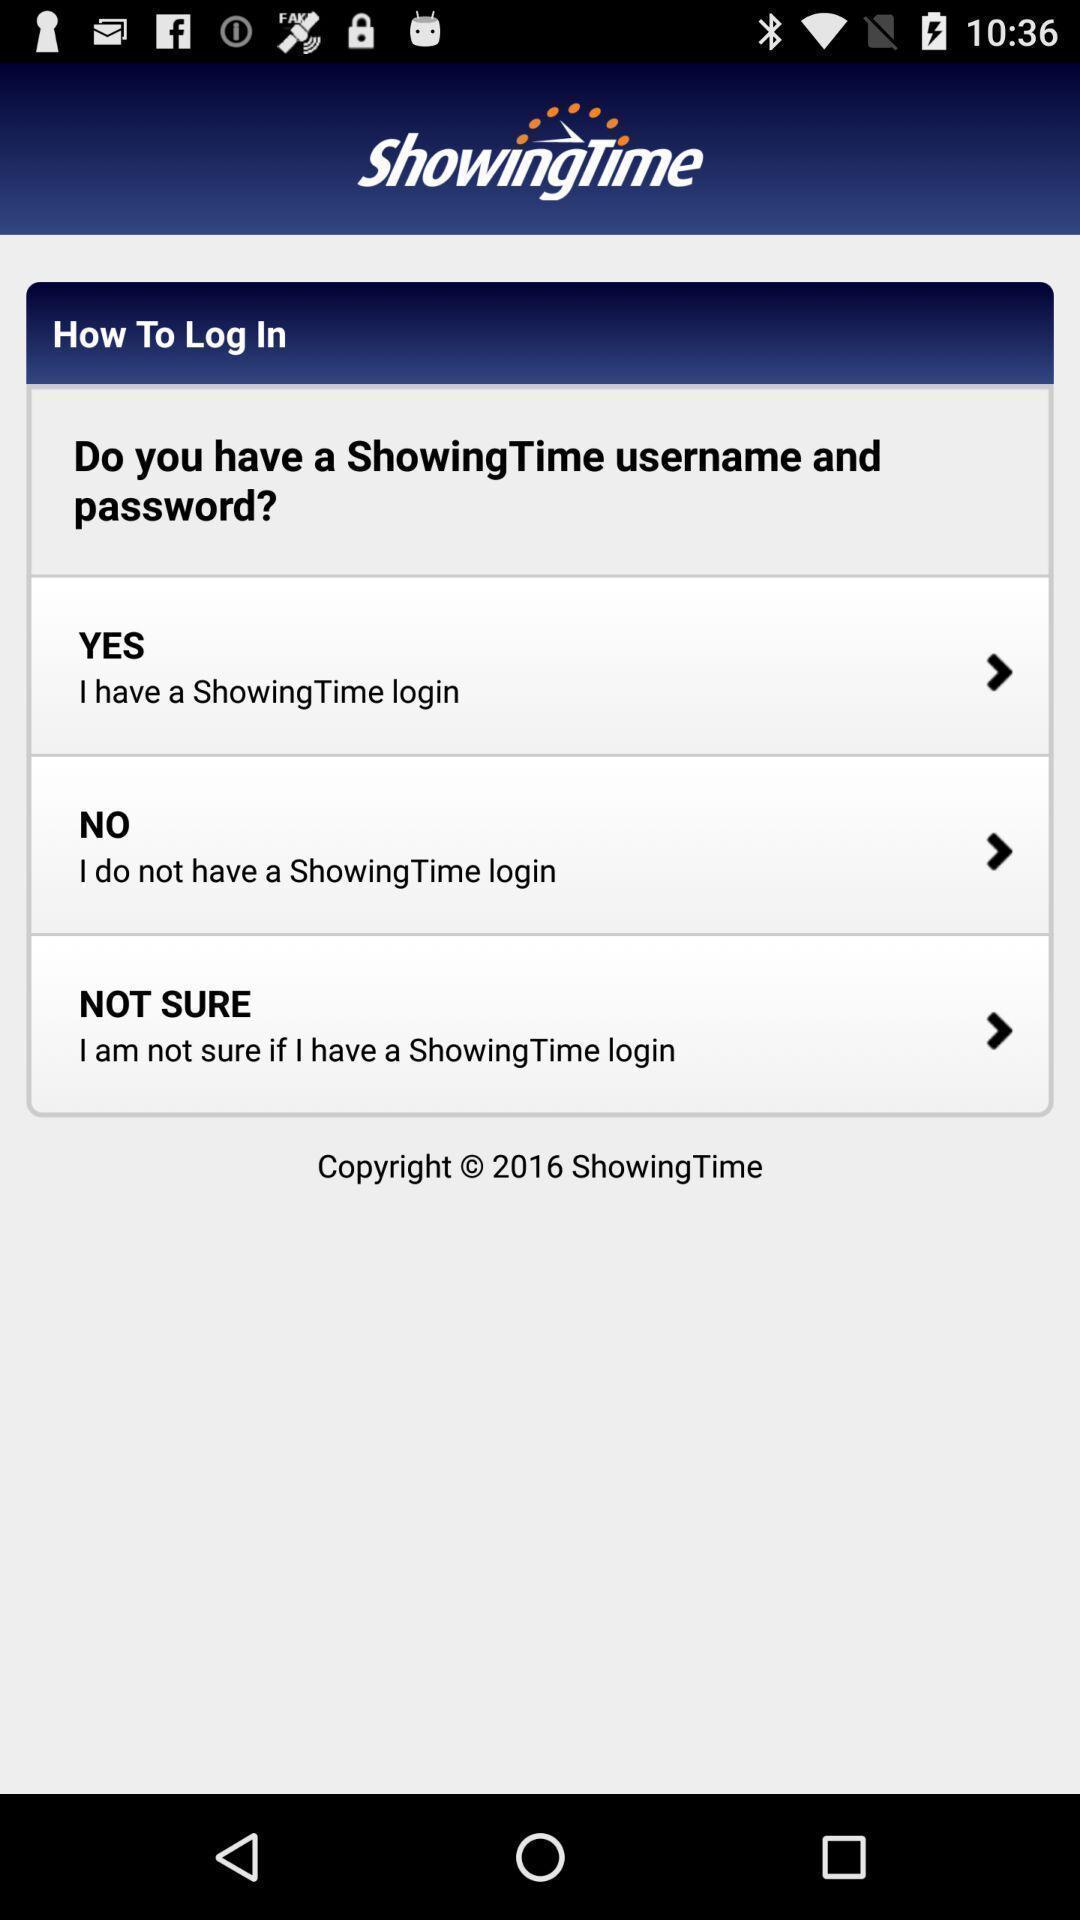Explain the elements present in this screenshot. Starting page of a real estate app showing a question. 